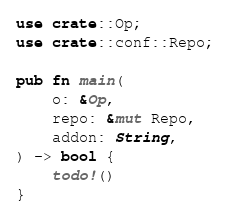<code> <loc_0><loc_0><loc_500><loc_500><_Rust_>use crate::Op;
use crate::conf::Repo;

pub fn main(
    o: &Op,
    repo: &mut Repo,
    addon: String,
) -> bool {
    todo!()
}
</code> 